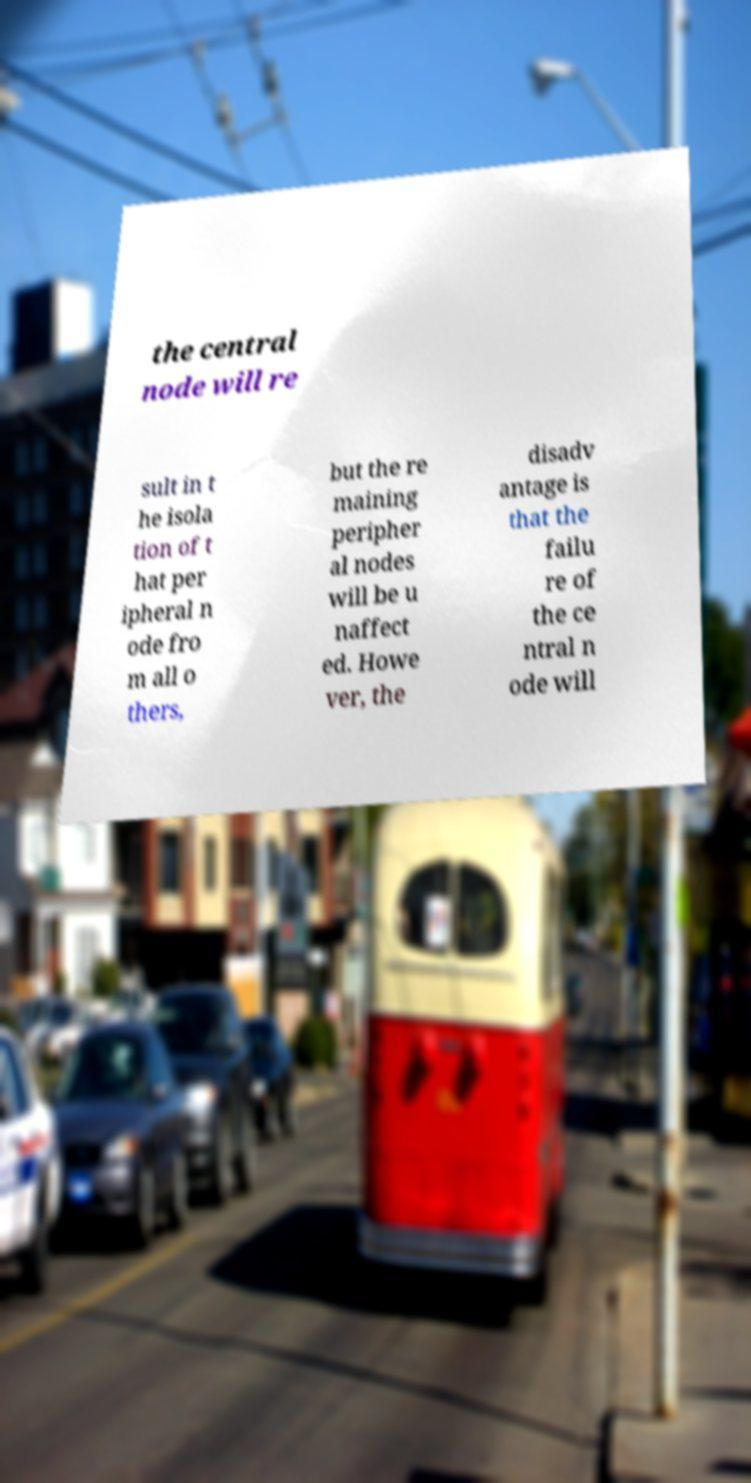There's text embedded in this image that I need extracted. Can you transcribe it verbatim? the central node will re sult in t he isola tion of t hat per ipheral n ode fro m all o thers, but the re maining peripher al nodes will be u naffect ed. Howe ver, the disadv antage is that the failu re of the ce ntral n ode will 